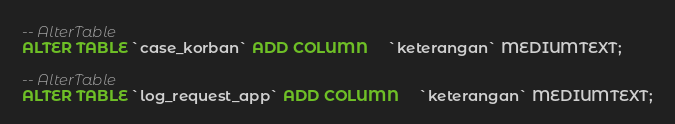Convert code to text. <code><loc_0><loc_0><loc_500><loc_500><_SQL_>
-- AlterTable
ALTER TABLE `case_korban` ADD COLUMN     `keterangan` MEDIUMTEXT;

-- AlterTable
ALTER TABLE `log_request_app` ADD COLUMN     `keterangan` MEDIUMTEXT;
</code> 